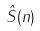<formula> <loc_0><loc_0><loc_500><loc_500>\hat { S } ( n )</formula> 